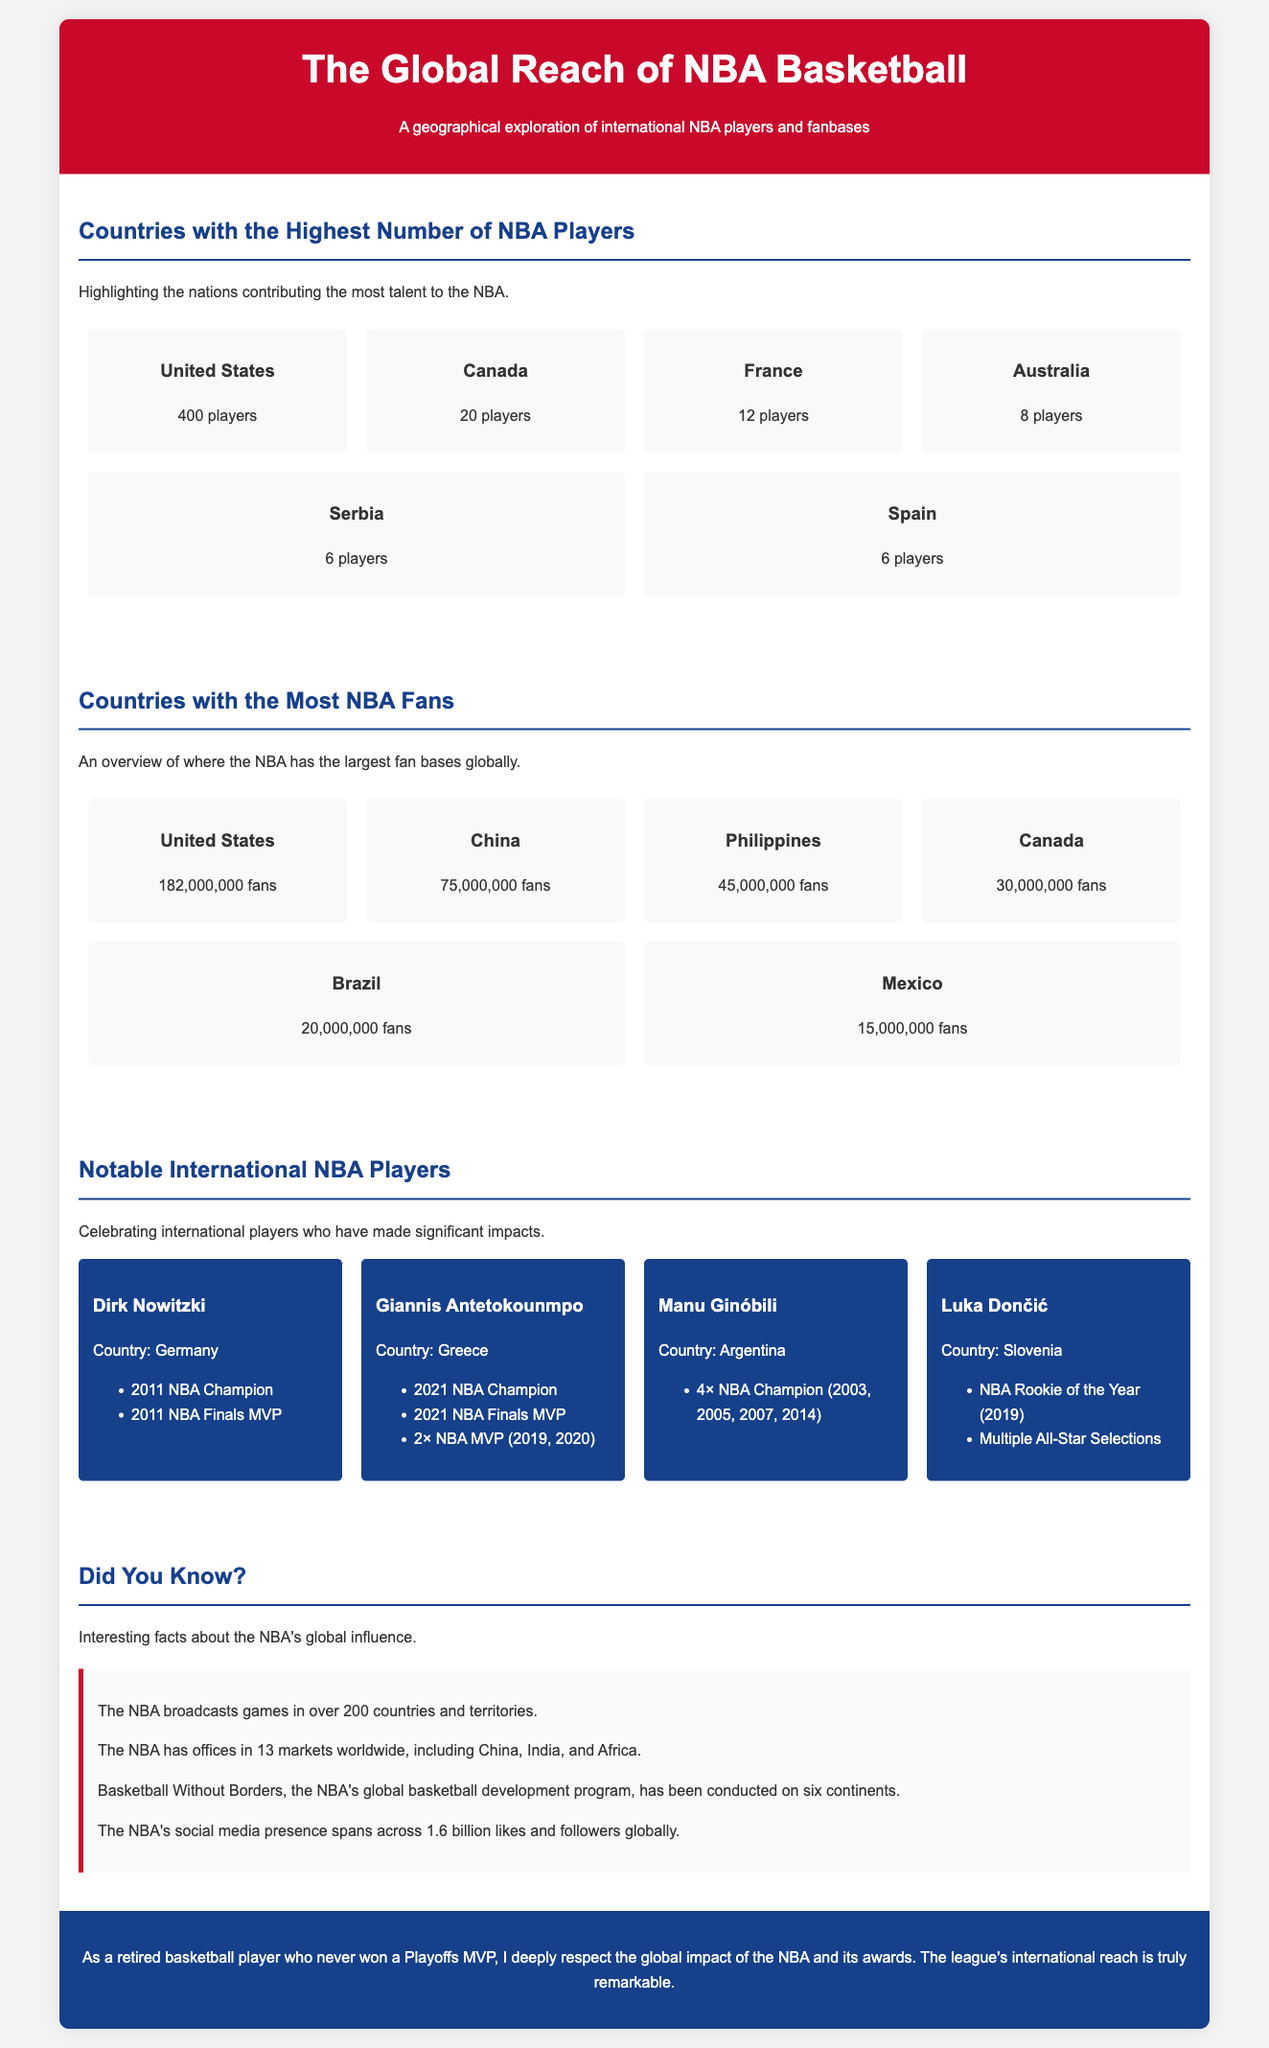What country has the most NBA players? The document indicates the United States as the country with the highest number of NBA players, which is 400.
Answer: United States How many NBA fans are in China? According to the document, China has a substantial NBA fan base totaling 75,000,000 fans.
Answer: 75,000,000 fans Which country has 30 million NBA fans? The stats section shows Canada having 30,000,000 fans of the NBA.
Answer: Canada Name one notable player from Serbia. From the highlighted section, the player associated with Serbia is Nikola Jokić.
Answer: Nikola Jokić Which country is listed with the fewest NBA players? In the document, both Spain and Serbia are tied with 6 players each, indicating they have the fewest within the listed nations.
Answer: Spain or Serbia Which country has the most NBA champions mentioned? The document highlights Manu Ginóbili from Argentina, who is a 4× NBA Champion. Thus, Argentina has the most championships mentioned.
Answer: Argentina What is the total number of fans for Mexico? The document specifies that Mexico has 15,000,000 fans of the NBA, which represents their fan base count.
Answer: 15,000,000 fans What program does the NBA have for global basketball development? The document mentions "Basketball Without Borders" as the NBA's global development program.
Answer: Basketball Without Borders How many players does Australia contribute to the NBA? According to the document, Australia contributes 8 players to the NBA.
Answer: 8 players 